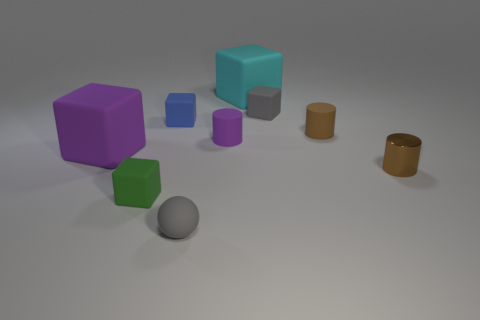Subtract all large cyan cubes. How many cubes are left? 4 Add 1 small blue matte blocks. How many objects exist? 10 Subtract all green blocks. How many blocks are left? 4 Subtract 3 blocks. How many blocks are left? 2 Subtract all balls. How many objects are left? 8 Subtract all gray cubes. Subtract all red cylinders. How many cubes are left? 4 Add 8 large rubber objects. How many large rubber objects are left? 10 Add 7 large gray matte balls. How many large gray matte balls exist? 7 Subtract 1 green blocks. How many objects are left? 8 Subtract all big brown metal spheres. Subtract all small objects. How many objects are left? 2 